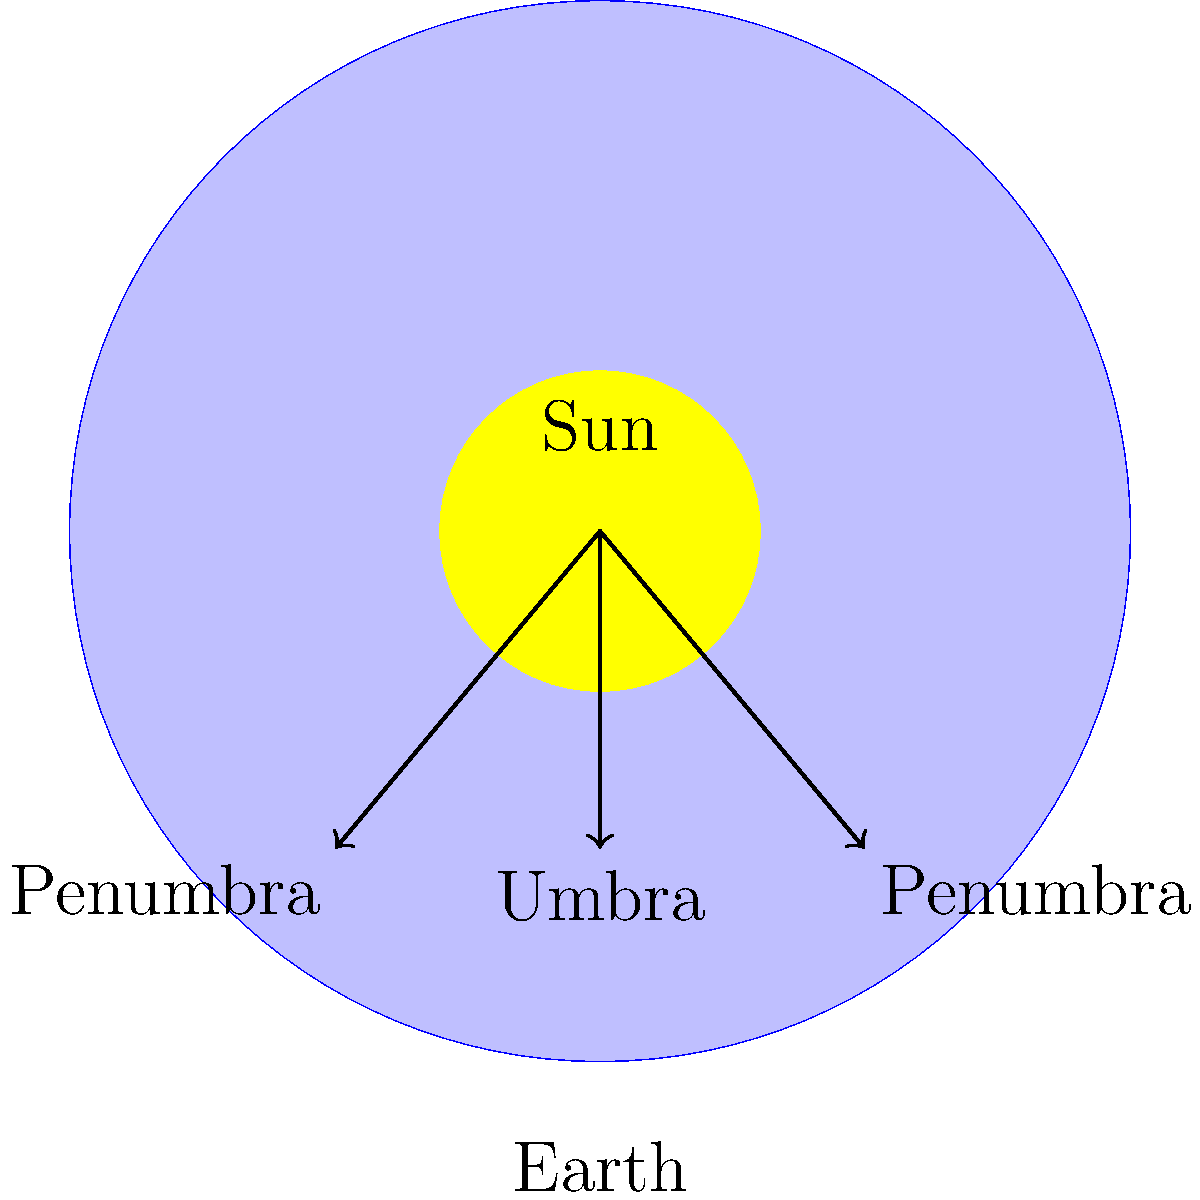As a local council member working on economic development initiatives, you're considering the potential tourism impact of an upcoming solar eclipse. Based on the diagram, which region on Earth would experience a total solar eclipse, and how does this relate to the visibility of the eclipse from different locations? To understand solar eclipses and their visibility from different locations on Earth, let's break down the diagram:

1. The large blue circle represents Earth, while the smaller yellow circle represents the Sun.

2. The diagram shows three key regions:
   a) Umbra: The central dark shadow directly behind Earth.
   b) Penumbra: The lighter outer shadows on either side of the umbra.

3. Total solar eclipse:
   - Occurs in the umbra region, where the Sun is completely blocked by the Moon.
   - Only visible from a narrow path on Earth's surface where the umbra touches.

4. Partial solar eclipse:
   - Visible from the penumbra regions.
   - Observers in these areas see only part of the Sun blocked by the Moon.

5. Visibility from different locations:
   - Total eclipse: Only visible from the narrow path of totality (umbra).
   - Partial eclipse: Visible from a much wider area (penumbra).
   - No eclipse: Areas outside both umbra and penumbra.

6. Duration and rarity:
   - Total eclipses are brief (usually a few minutes) and occur rarely in any given location.
   - Partial eclipses are more common and last longer.

7. Tourism impact:
   - Total eclipses often draw significant tourism due to their rarity and spectacular nature.
   - Areas in the path of totality can experience a substantial economic boost.

Understanding these factors helps in planning for potential tourism opportunities and necessary infrastructure to accommodate visitors during the eclipse event.
Answer: The umbra region experiences a total solar eclipse, visible only from a narrow path on Earth's surface, while broader areas in the penumbra see a partial eclipse. 